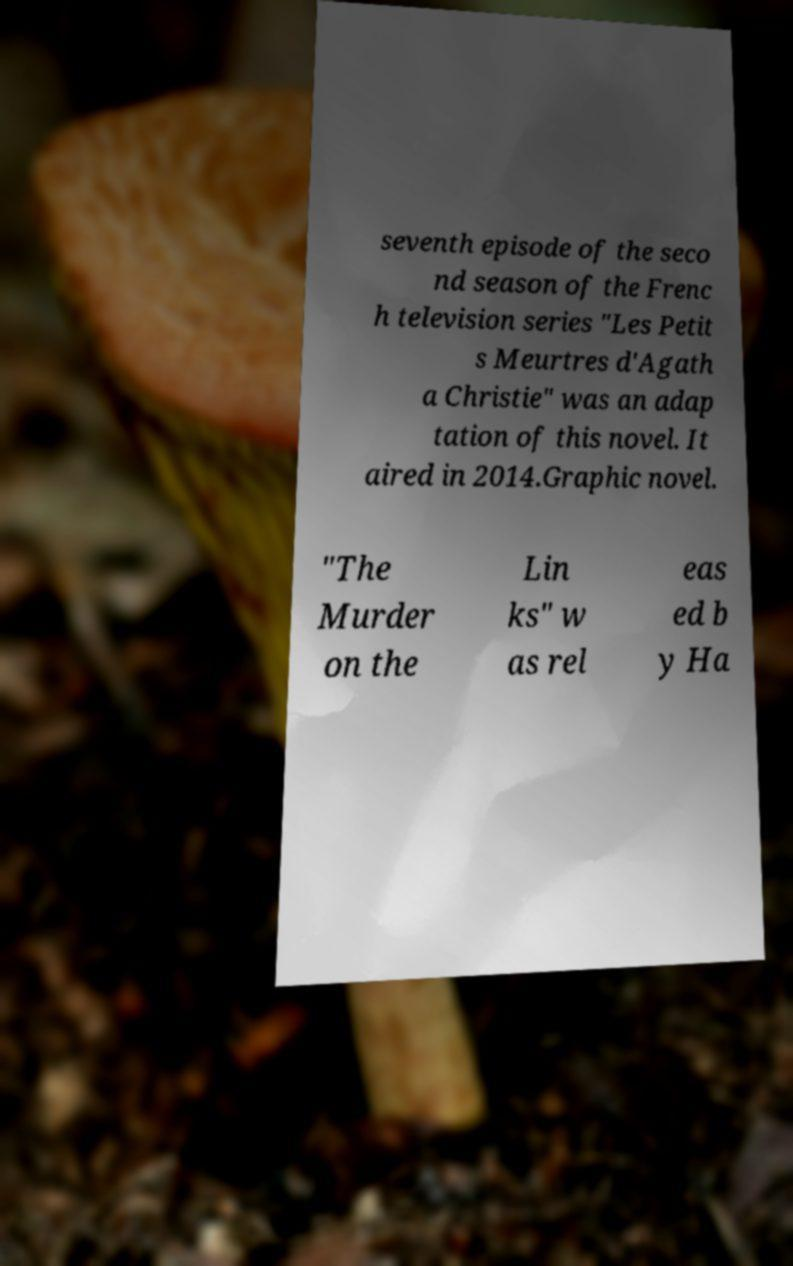I need the written content from this picture converted into text. Can you do that? seventh episode of the seco nd season of the Frenc h television series "Les Petit s Meurtres d'Agath a Christie" was an adap tation of this novel. It aired in 2014.Graphic novel. "The Murder on the Lin ks" w as rel eas ed b y Ha 